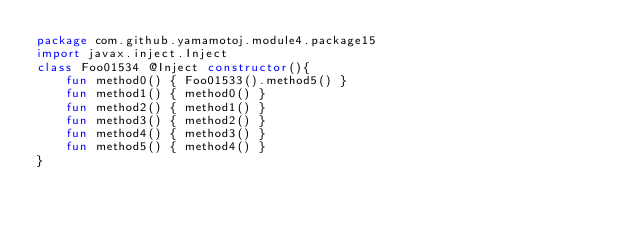<code> <loc_0><loc_0><loc_500><loc_500><_Kotlin_>package com.github.yamamotoj.module4.package15
import javax.inject.Inject
class Foo01534 @Inject constructor(){
    fun method0() { Foo01533().method5() }
    fun method1() { method0() }
    fun method2() { method1() }
    fun method3() { method2() }
    fun method4() { method3() }
    fun method5() { method4() }
}
</code> 